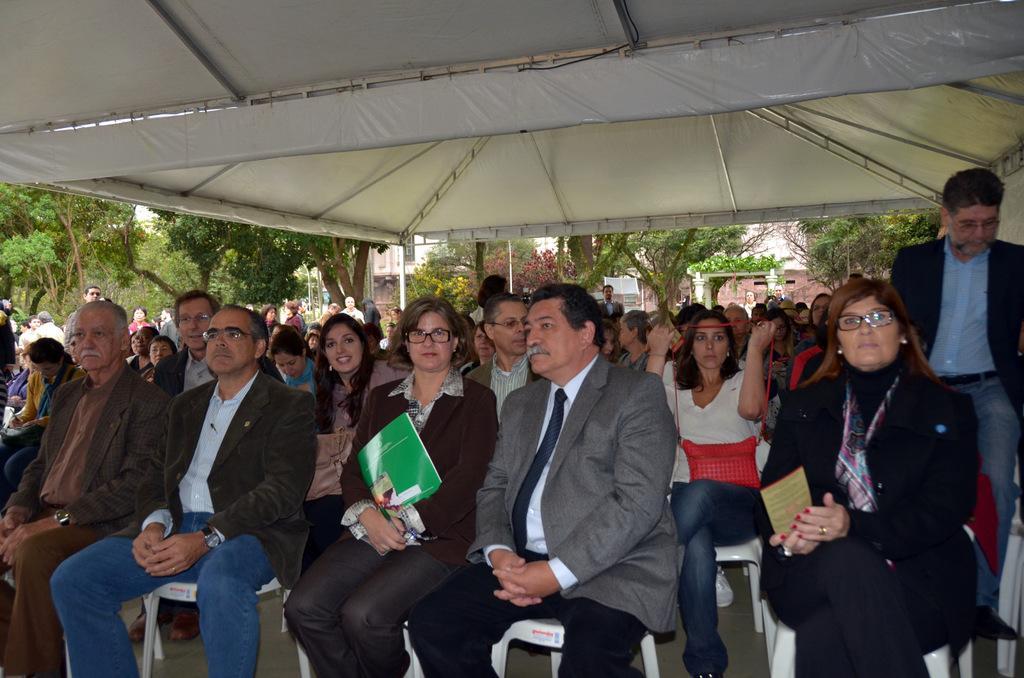In one or two sentences, can you explain what this image depicts? In this picture we can see some people are sitting on chairs, there is a tent at the top of the picture, in the background we can see buildings and trees, there are some people standing in the middle. 